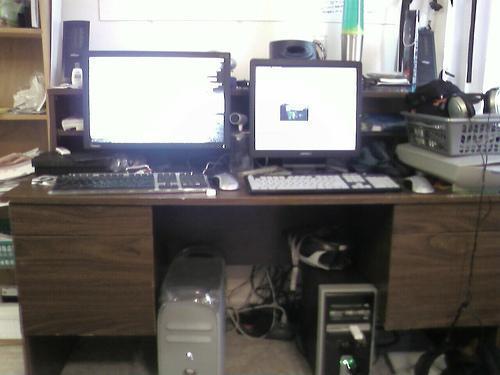How many monitors are there?
Give a very brief answer. 2. How many keyboards can be seen?
Give a very brief answer. 2. How many tvs are in the picture?
Give a very brief answer. 2. How many zebras are eating off the ground?
Give a very brief answer. 0. 